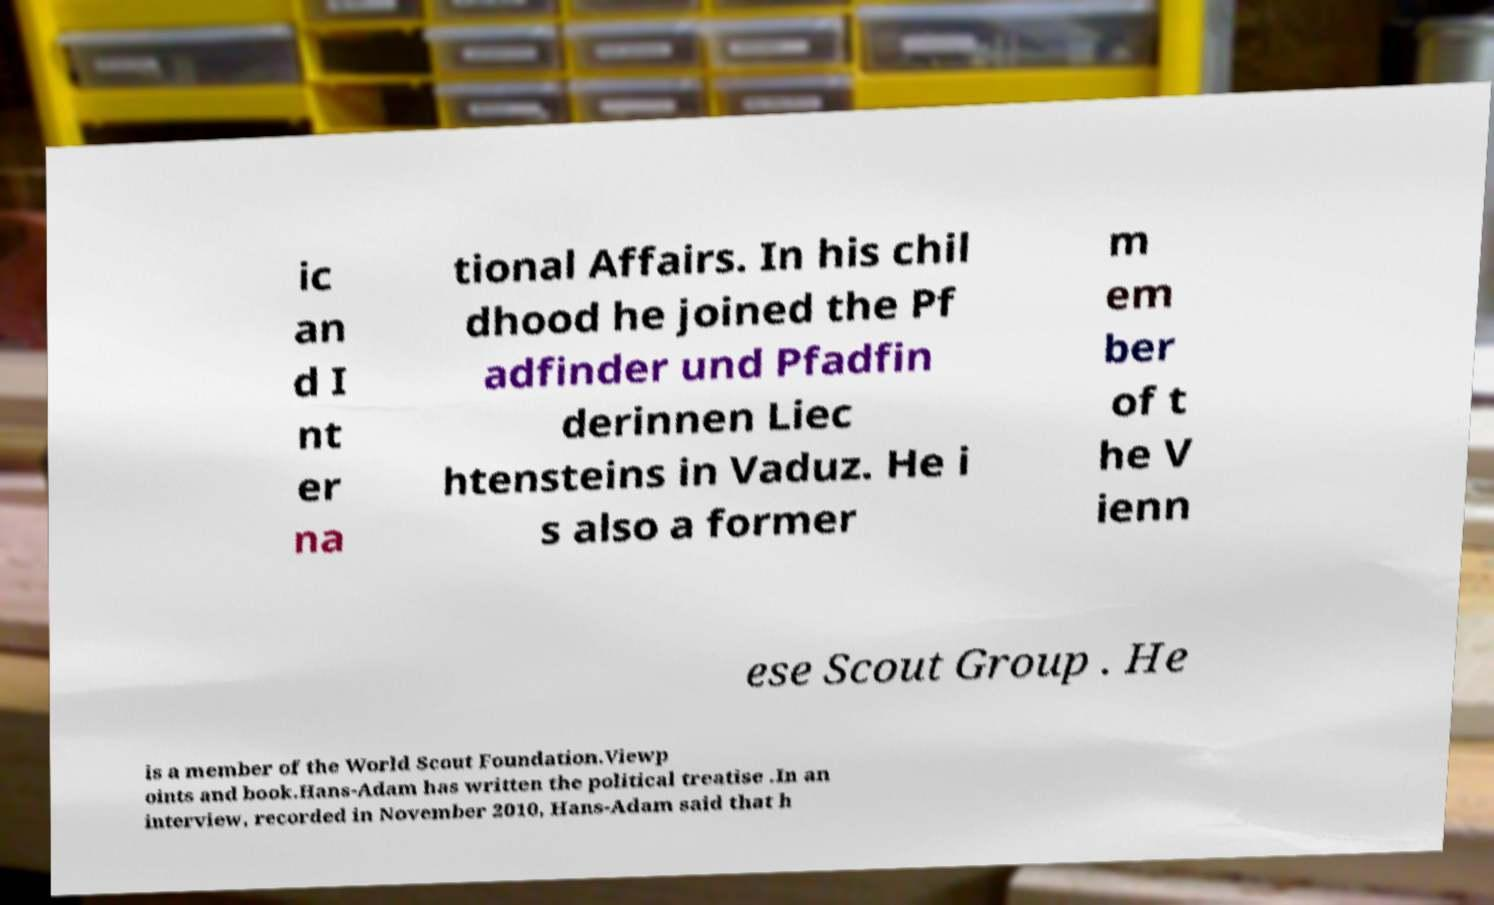What messages or text are displayed in this image? I need them in a readable, typed format. ic an d I nt er na tional Affairs. In his chil dhood he joined the Pf adfinder und Pfadfin derinnen Liec htensteins in Vaduz. He i s also a former m em ber of t he V ienn ese Scout Group . He is a member of the World Scout Foundation.Viewp oints and book.Hans-Adam has written the political treatise .In an interview, recorded in November 2010, Hans-Adam said that h 